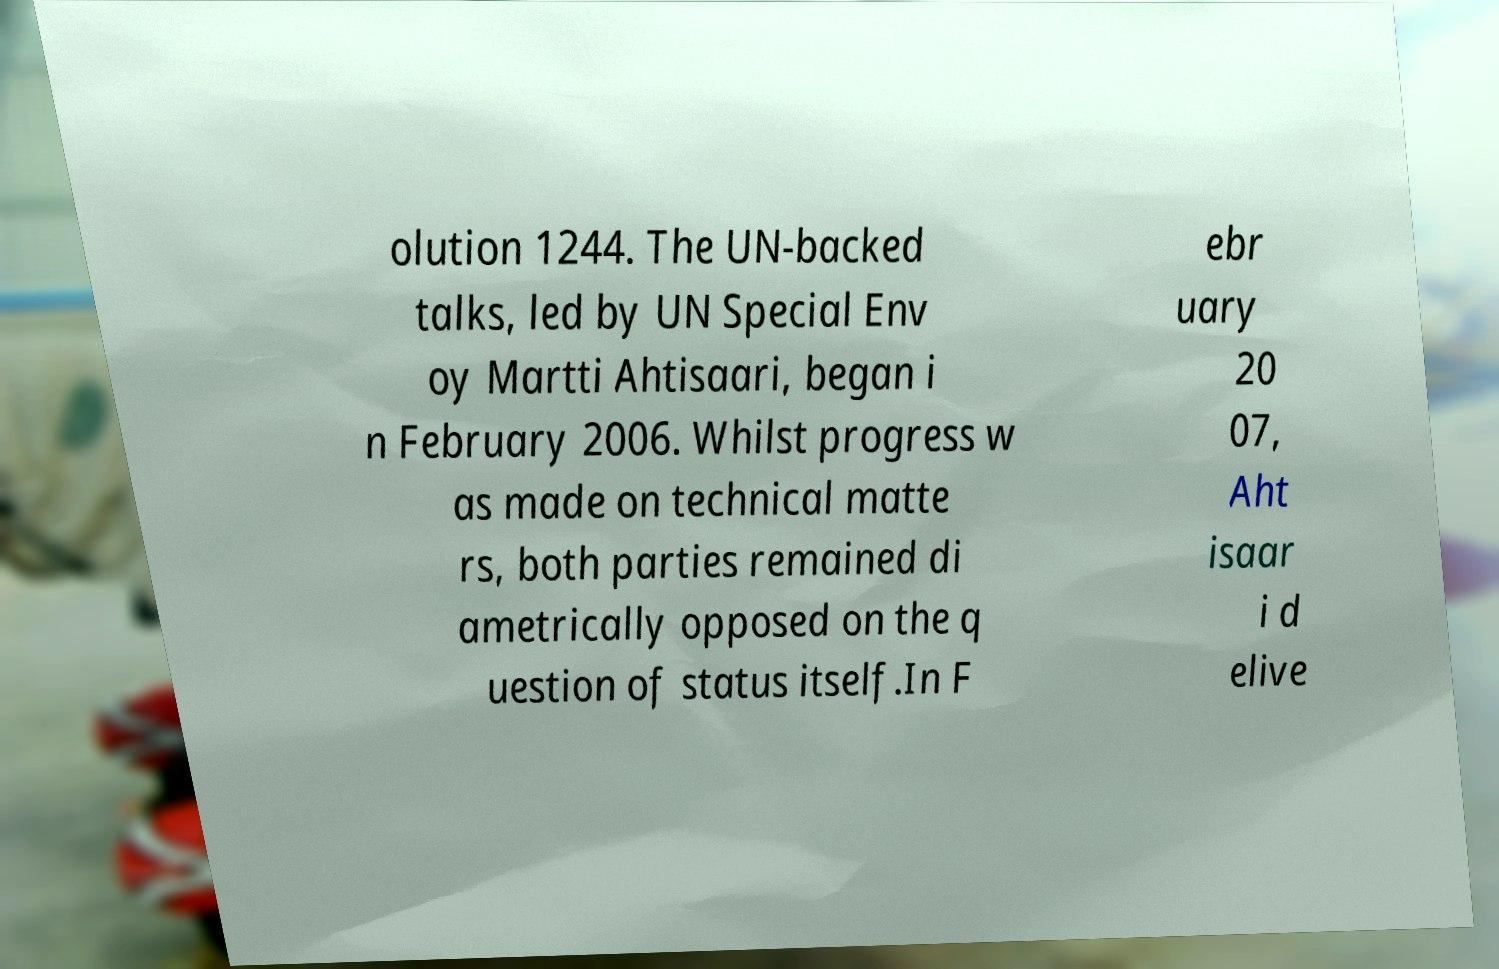What messages or text are displayed in this image? I need them in a readable, typed format. olution 1244. The UN-backed talks, led by UN Special Env oy Martti Ahtisaari, began i n February 2006. Whilst progress w as made on technical matte rs, both parties remained di ametrically opposed on the q uestion of status itself.In F ebr uary 20 07, Aht isaar i d elive 